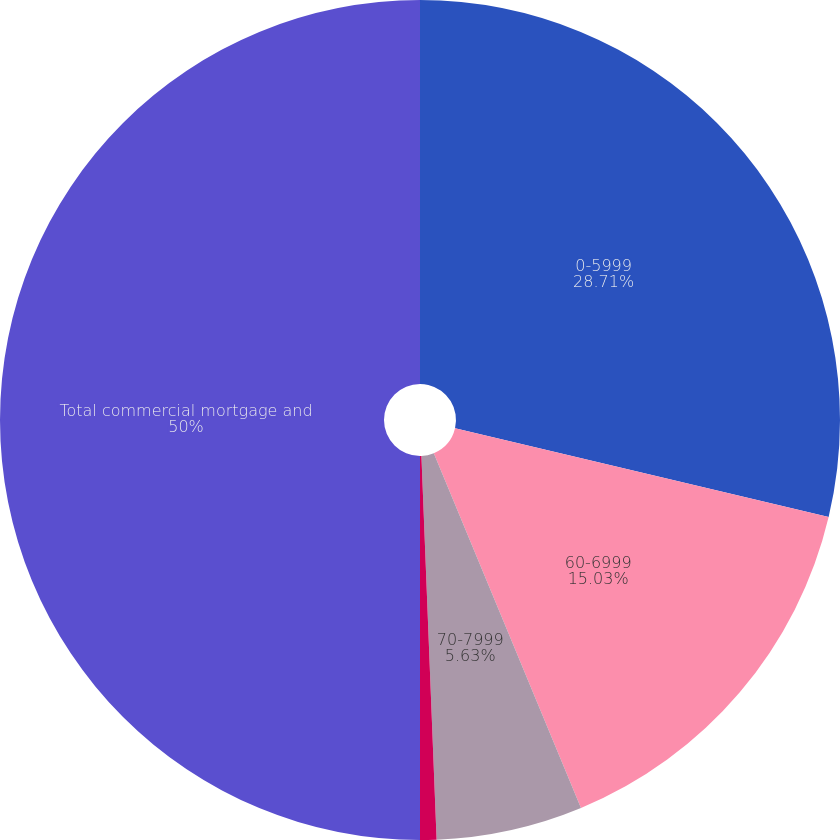Convert chart to OTSL. <chart><loc_0><loc_0><loc_500><loc_500><pie_chart><fcel>0-5999<fcel>60-6999<fcel>70-7999<fcel>Greater than 80<fcel>Total commercial mortgage and<nl><fcel>28.71%<fcel>15.03%<fcel>5.63%<fcel>0.63%<fcel>50.0%<nl></chart> 